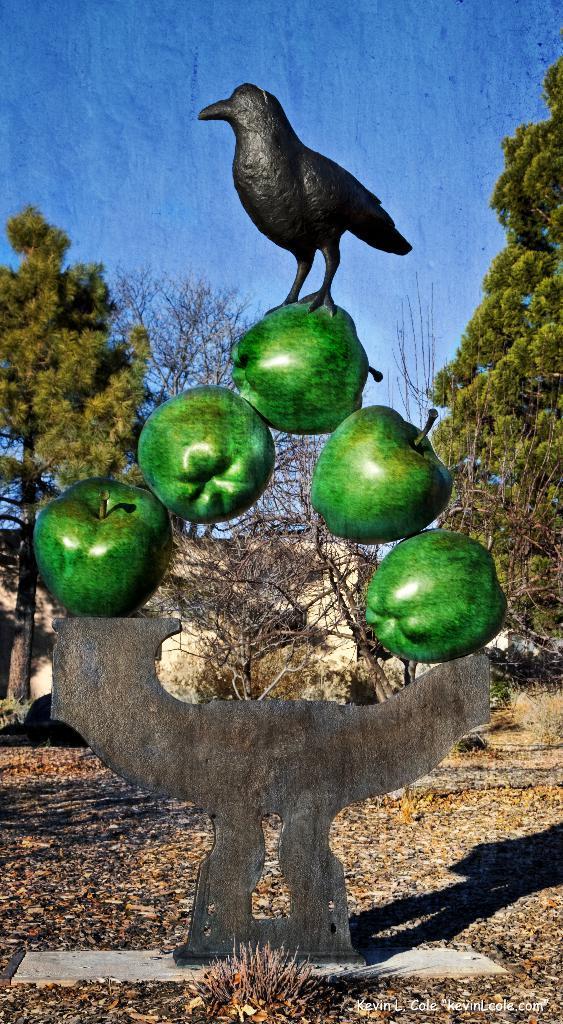Please provide a concise description of this image. In this image I can see a sculpture in the front. In the background I can see few trees, a building and the sky. 